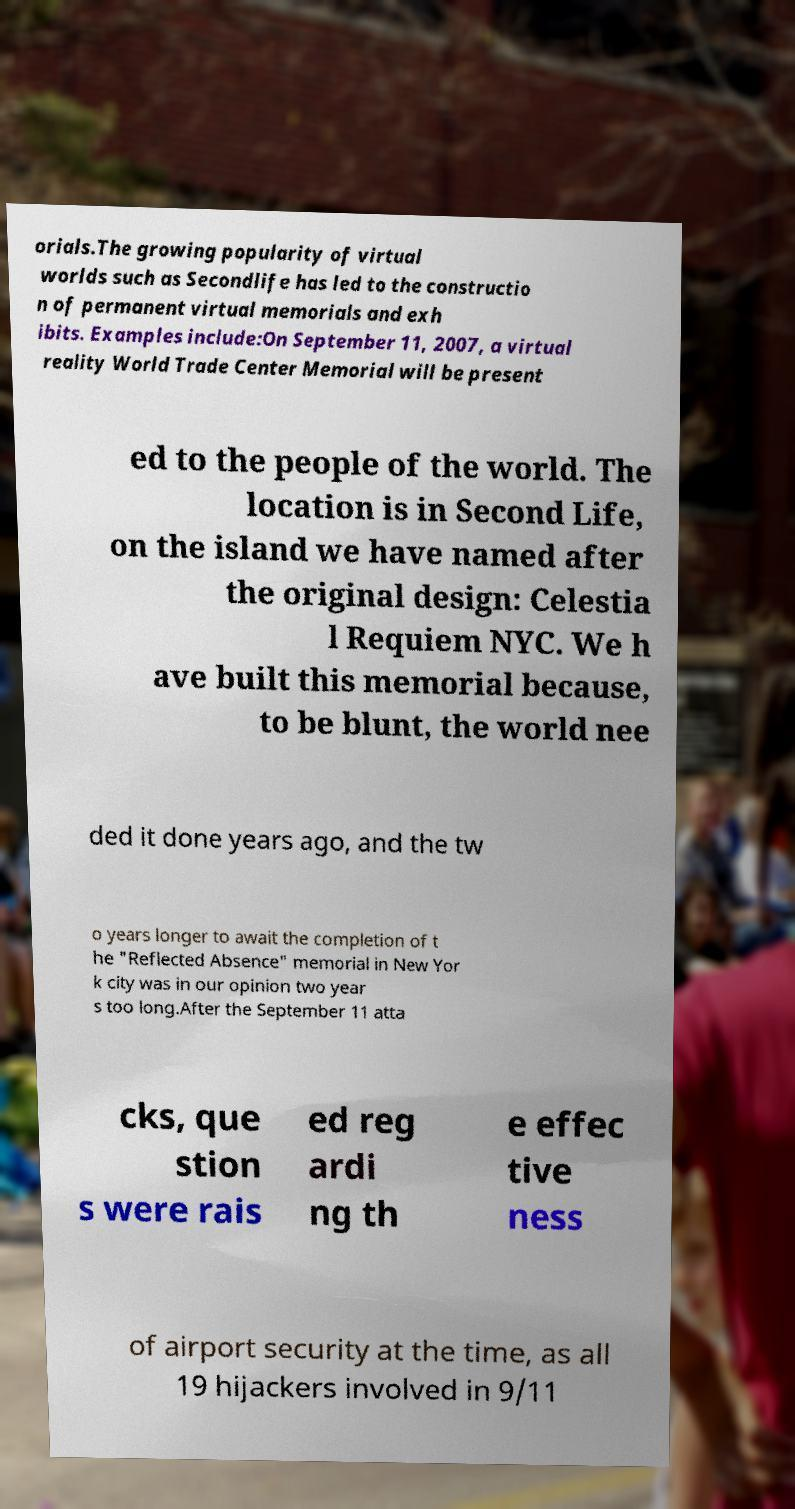Could you assist in decoding the text presented in this image and type it out clearly? orials.The growing popularity of virtual worlds such as Secondlife has led to the constructio n of permanent virtual memorials and exh ibits. Examples include:On September 11, 2007, a virtual reality World Trade Center Memorial will be present ed to the people of the world. The location is in Second Life, on the island we have named after the original design: Celestia l Requiem NYC. We h ave built this memorial because, to be blunt, the world nee ded it done years ago, and the tw o years longer to await the completion of t he "Reflected Absence" memorial in New Yor k city was in our opinion two year s too long.After the September 11 atta cks, que stion s were rais ed reg ardi ng th e effec tive ness of airport security at the time, as all 19 hijackers involved in 9/11 